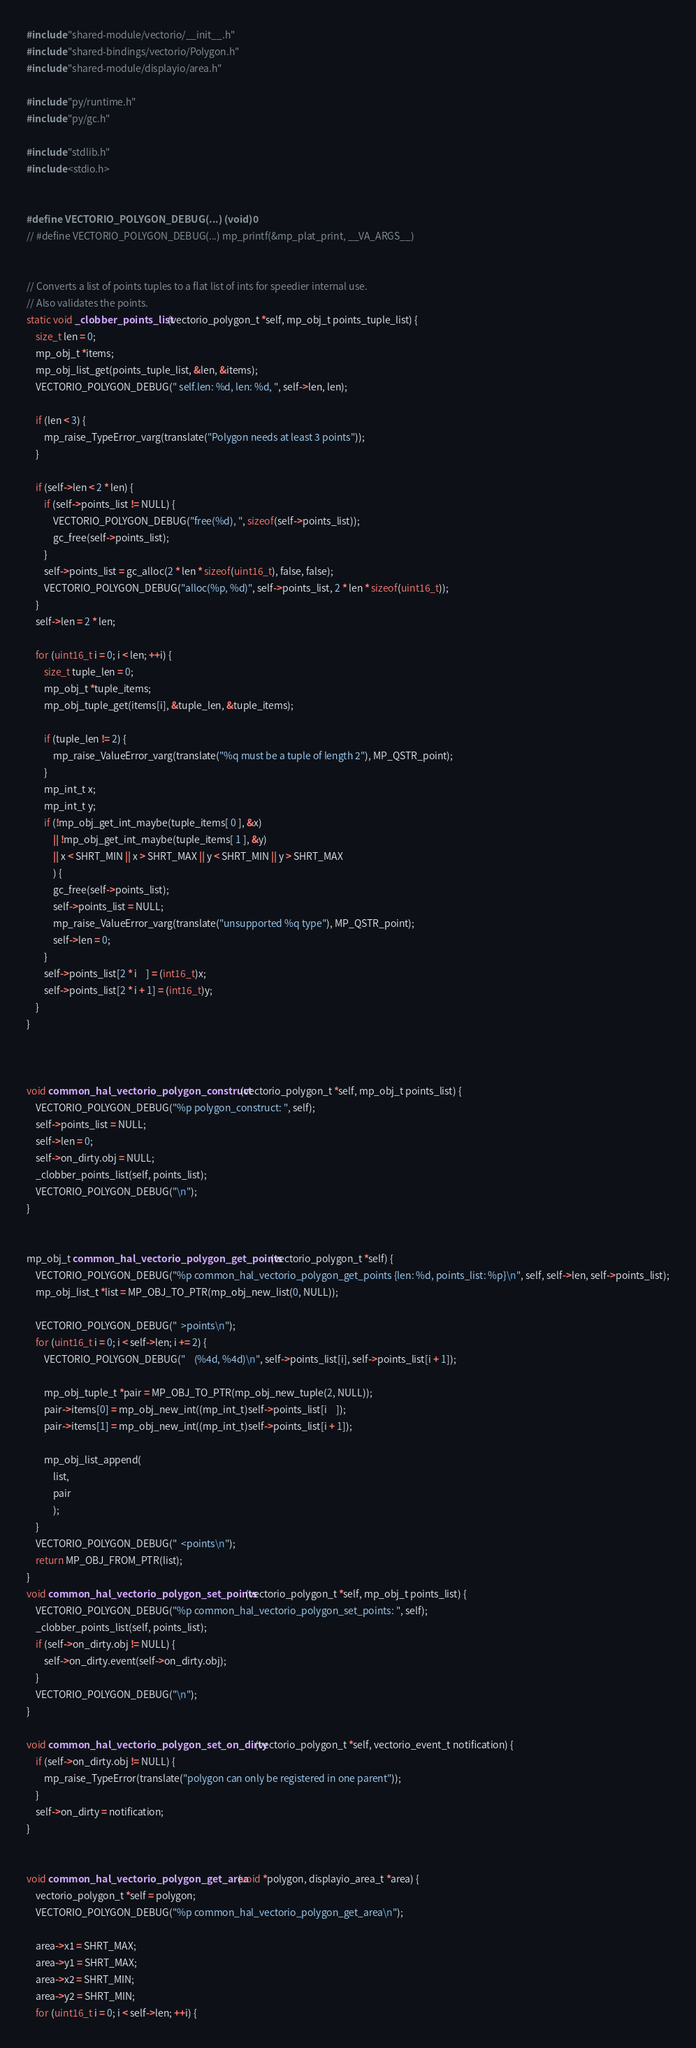<code> <loc_0><loc_0><loc_500><loc_500><_C_>#include "shared-module/vectorio/__init__.h"
#include "shared-bindings/vectorio/Polygon.h"
#include "shared-module/displayio/area.h"

#include "py/runtime.h"
#include "py/gc.h"

#include "stdlib.h"
#include <stdio.h>


#define VECTORIO_POLYGON_DEBUG(...) (void)0
// #define VECTORIO_POLYGON_DEBUG(...) mp_printf(&mp_plat_print, __VA_ARGS__)


// Converts a list of points tuples to a flat list of ints for speedier internal use.
// Also validates the points.
static void _clobber_points_list(vectorio_polygon_t *self, mp_obj_t points_tuple_list) {
    size_t len = 0;
    mp_obj_t *items;
    mp_obj_list_get(points_tuple_list, &len, &items);
    VECTORIO_POLYGON_DEBUG(" self.len: %d, len: %d, ", self->len, len);

    if (len < 3) {
        mp_raise_TypeError_varg(translate("Polygon needs at least 3 points"));
    }

    if (self->len < 2 * len) {
        if (self->points_list != NULL) {
            VECTORIO_POLYGON_DEBUG("free(%d), ", sizeof(self->points_list));
            gc_free(self->points_list);
        }
        self->points_list = gc_alloc(2 * len * sizeof(uint16_t), false, false);
        VECTORIO_POLYGON_DEBUG("alloc(%p, %d)", self->points_list, 2 * len * sizeof(uint16_t));
    }
    self->len = 2 * len;

    for (uint16_t i = 0; i < len; ++i) {
        size_t tuple_len = 0;
        mp_obj_t *tuple_items;
        mp_obj_tuple_get(items[i], &tuple_len, &tuple_items);

        if (tuple_len != 2) {
            mp_raise_ValueError_varg(translate("%q must be a tuple of length 2"), MP_QSTR_point);
        }
        mp_int_t x;
        mp_int_t y;
        if (!mp_obj_get_int_maybe(tuple_items[ 0 ], &x)
            || !mp_obj_get_int_maybe(tuple_items[ 1 ], &y)
            || x < SHRT_MIN || x > SHRT_MAX || y < SHRT_MIN || y > SHRT_MAX
            ) {
            gc_free(self->points_list);
            self->points_list = NULL;
            mp_raise_ValueError_varg(translate("unsupported %q type"), MP_QSTR_point);
            self->len = 0;
        }
        self->points_list[2 * i    ] = (int16_t)x;
        self->points_list[2 * i + 1] = (int16_t)y;
    }
}



void common_hal_vectorio_polygon_construct(vectorio_polygon_t *self, mp_obj_t points_list) {
    VECTORIO_POLYGON_DEBUG("%p polygon_construct: ", self);
    self->points_list = NULL;
    self->len = 0;
    self->on_dirty.obj = NULL;
    _clobber_points_list(self, points_list);
    VECTORIO_POLYGON_DEBUG("\n");
}


mp_obj_t common_hal_vectorio_polygon_get_points(vectorio_polygon_t *self) {
    VECTORIO_POLYGON_DEBUG("%p common_hal_vectorio_polygon_get_points {len: %d, points_list: %p}\n", self, self->len, self->points_list);
    mp_obj_list_t *list = MP_OBJ_TO_PTR(mp_obj_new_list(0, NULL));

    VECTORIO_POLYGON_DEBUG("  >points\n");
    for (uint16_t i = 0; i < self->len; i += 2) {
        VECTORIO_POLYGON_DEBUG("    (%4d, %4d)\n", self->points_list[i], self->points_list[i + 1]);

        mp_obj_tuple_t *pair = MP_OBJ_TO_PTR(mp_obj_new_tuple(2, NULL));
        pair->items[0] = mp_obj_new_int((mp_int_t)self->points_list[i    ]);
        pair->items[1] = mp_obj_new_int((mp_int_t)self->points_list[i + 1]);

        mp_obj_list_append(
            list,
            pair
            );
    }
    VECTORIO_POLYGON_DEBUG("  <points\n");
    return MP_OBJ_FROM_PTR(list);
}
void common_hal_vectorio_polygon_set_points(vectorio_polygon_t *self, mp_obj_t points_list) {
    VECTORIO_POLYGON_DEBUG("%p common_hal_vectorio_polygon_set_points: ", self);
    _clobber_points_list(self, points_list);
    if (self->on_dirty.obj != NULL) {
        self->on_dirty.event(self->on_dirty.obj);
    }
    VECTORIO_POLYGON_DEBUG("\n");
}

void common_hal_vectorio_polygon_set_on_dirty(vectorio_polygon_t *self, vectorio_event_t notification) {
    if (self->on_dirty.obj != NULL) {
        mp_raise_TypeError(translate("polygon can only be registered in one parent"));
    }
    self->on_dirty = notification;
}


void common_hal_vectorio_polygon_get_area(void *polygon, displayio_area_t *area) {
    vectorio_polygon_t *self = polygon;
    VECTORIO_POLYGON_DEBUG("%p common_hal_vectorio_polygon_get_area\n");

    area->x1 = SHRT_MAX;
    area->y1 = SHRT_MAX;
    area->x2 = SHRT_MIN;
    area->y2 = SHRT_MIN;
    for (uint16_t i = 0; i < self->len; ++i) {</code> 